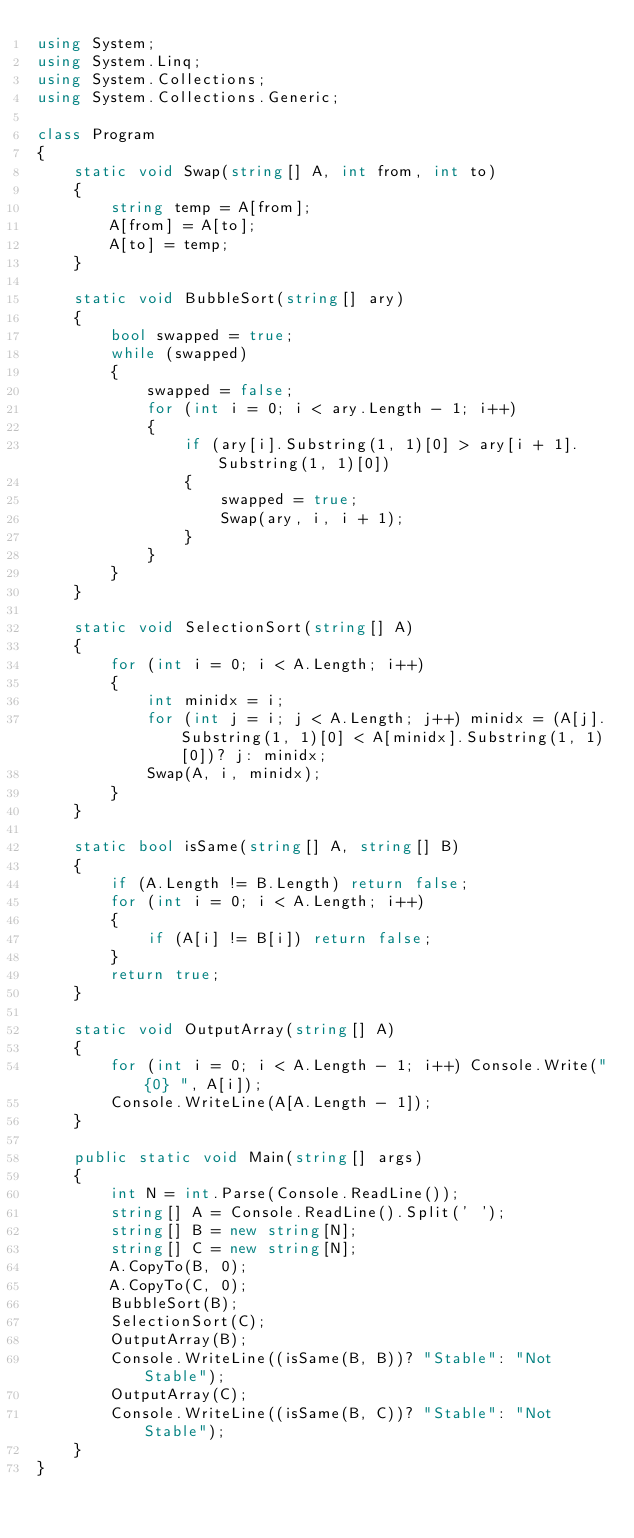<code> <loc_0><loc_0><loc_500><loc_500><_C#_>using System;
using System.Linq;
using System.Collections;
using System.Collections.Generic;

class Program
{
    static void Swap(string[] A, int from, int to)
    {
        string temp = A[from];
        A[from] = A[to];
        A[to] = temp;
    }

    static void BubbleSort(string[] ary)
    {
        bool swapped = true;
        while (swapped)
        {
            swapped = false;
            for (int i = 0; i < ary.Length - 1; i++)
            {
                if (ary[i].Substring(1, 1)[0] > ary[i + 1].Substring(1, 1)[0])
                {
                    swapped = true;
                    Swap(ary, i, i + 1);
                }             
            }
        }
    }

    static void SelectionSort(string[] A)
    {
        for (int i = 0; i < A.Length; i++)
        {
            int minidx = i;
            for (int j = i; j < A.Length; j++) minidx = (A[j].Substring(1, 1)[0] < A[minidx].Substring(1, 1)[0])? j: minidx;
            Swap(A, i, minidx);
        }
    }

    static bool isSame(string[] A, string[] B)
    {
        if (A.Length != B.Length) return false;
        for (int i = 0; i < A.Length; i++)
        {
            if (A[i] != B[i]) return false;
        }
        return true;
    }

    static void OutputArray(string[] A)
    {
        for (int i = 0; i < A.Length - 1; i++) Console.Write("{0} ", A[i]);
        Console.WriteLine(A[A.Length - 1]);
    }

    public static void Main(string[] args)
    {
        int N = int.Parse(Console.ReadLine());
        string[] A = Console.ReadLine().Split(' ');
        string[] B = new string[N];
        string[] C = new string[N];
        A.CopyTo(B, 0);
        A.CopyTo(C, 0);
        BubbleSort(B);
        SelectionSort(C);
        OutputArray(B);
        Console.WriteLine((isSame(B, B))? "Stable": "Not Stable");
        OutputArray(C);
        Console.WriteLine((isSame(B, C))? "Stable": "Not Stable");
    }
}
</code> 